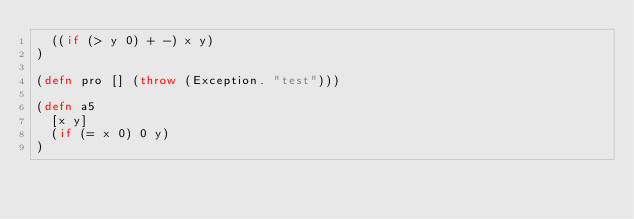<code> <loc_0><loc_0><loc_500><loc_500><_Clojure_>	((if (> y 0) + -) x y)
)

(defn pro [] (throw (Exception. "test")))

(defn a5
	[x y]
	(if (= x 0) 0 y)
)
</code> 